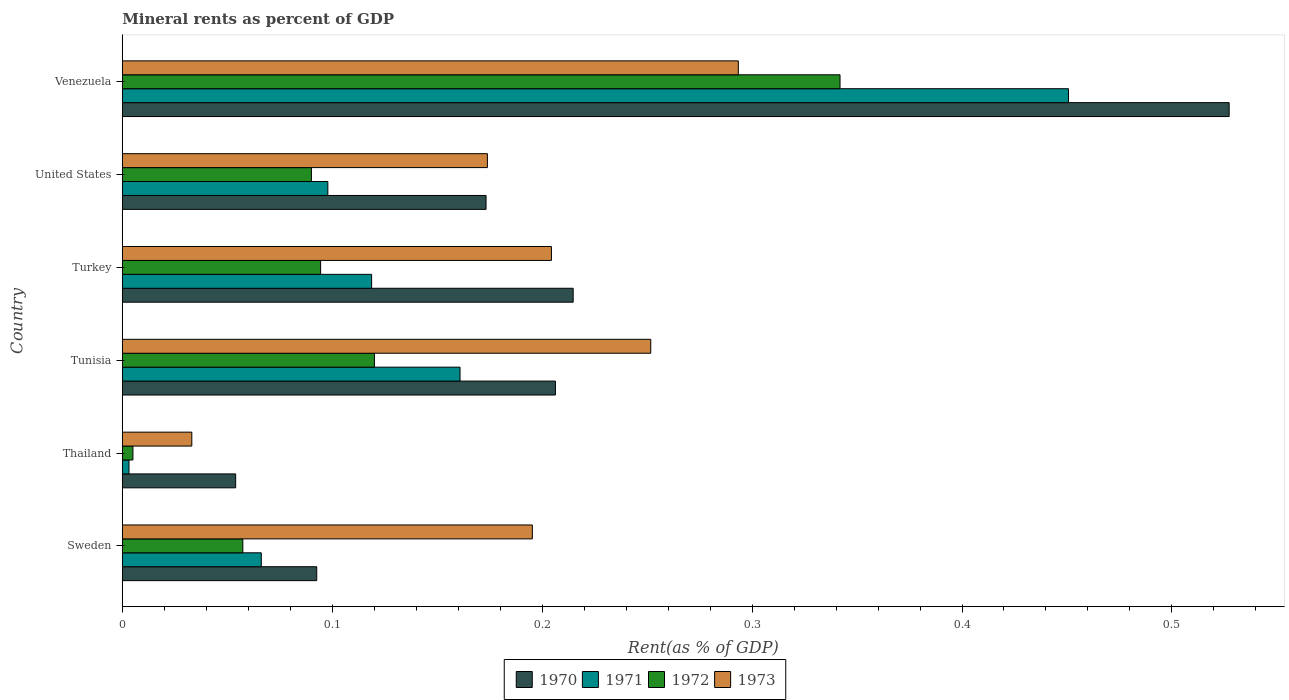How many different coloured bars are there?
Make the answer very short. 4. How many groups of bars are there?
Provide a short and direct response. 6. Are the number of bars per tick equal to the number of legend labels?
Give a very brief answer. Yes. How many bars are there on the 2nd tick from the top?
Offer a terse response. 4. In how many cases, is the number of bars for a given country not equal to the number of legend labels?
Provide a succinct answer. 0. What is the mineral rent in 1973 in Sweden?
Offer a terse response. 0.2. Across all countries, what is the maximum mineral rent in 1973?
Provide a succinct answer. 0.29. Across all countries, what is the minimum mineral rent in 1972?
Offer a terse response. 0.01. In which country was the mineral rent in 1970 maximum?
Provide a short and direct response. Venezuela. In which country was the mineral rent in 1971 minimum?
Your answer should be compact. Thailand. What is the total mineral rent in 1970 in the graph?
Ensure brevity in your answer.  1.27. What is the difference between the mineral rent in 1971 in Thailand and that in Turkey?
Ensure brevity in your answer.  -0.12. What is the difference between the mineral rent in 1973 in Venezuela and the mineral rent in 1971 in Turkey?
Your answer should be compact. 0.17. What is the average mineral rent in 1971 per country?
Keep it short and to the point. 0.15. What is the difference between the mineral rent in 1971 and mineral rent in 1970 in Turkey?
Your answer should be very brief. -0.1. In how many countries, is the mineral rent in 1972 greater than 0.2 %?
Give a very brief answer. 1. What is the ratio of the mineral rent in 1972 in Thailand to that in Venezuela?
Offer a terse response. 0.01. What is the difference between the highest and the second highest mineral rent in 1970?
Your response must be concise. 0.31. What is the difference between the highest and the lowest mineral rent in 1971?
Offer a terse response. 0.45. Is the sum of the mineral rent in 1970 in Tunisia and Venezuela greater than the maximum mineral rent in 1971 across all countries?
Make the answer very short. Yes. Is it the case that in every country, the sum of the mineral rent in 1973 and mineral rent in 1971 is greater than the sum of mineral rent in 1972 and mineral rent in 1970?
Provide a succinct answer. No. What does the 2nd bar from the top in Turkey represents?
Offer a terse response. 1972. How many bars are there?
Keep it short and to the point. 24. Are all the bars in the graph horizontal?
Provide a short and direct response. Yes. How many countries are there in the graph?
Offer a very short reply. 6. Are the values on the major ticks of X-axis written in scientific E-notation?
Offer a terse response. No. How many legend labels are there?
Your response must be concise. 4. What is the title of the graph?
Make the answer very short. Mineral rents as percent of GDP. What is the label or title of the X-axis?
Ensure brevity in your answer.  Rent(as % of GDP). What is the Rent(as % of GDP) of 1970 in Sweden?
Your answer should be very brief. 0.09. What is the Rent(as % of GDP) of 1971 in Sweden?
Keep it short and to the point. 0.07. What is the Rent(as % of GDP) in 1972 in Sweden?
Keep it short and to the point. 0.06. What is the Rent(as % of GDP) in 1973 in Sweden?
Your answer should be very brief. 0.2. What is the Rent(as % of GDP) of 1970 in Thailand?
Your answer should be very brief. 0.05. What is the Rent(as % of GDP) of 1971 in Thailand?
Provide a short and direct response. 0. What is the Rent(as % of GDP) of 1972 in Thailand?
Ensure brevity in your answer.  0.01. What is the Rent(as % of GDP) in 1973 in Thailand?
Offer a terse response. 0.03. What is the Rent(as % of GDP) in 1970 in Tunisia?
Your answer should be very brief. 0.21. What is the Rent(as % of GDP) in 1971 in Tunisia?
Offer a very short reply. 0.16. What is the Rent(as % of GDP) in 1972 in Tunisia?
Your response must be concise. 0.12. What is the Rent(as % of GDP) in 1973 in Tunisia?
Provide a short and direct response. 0.25. What is the Rent(as % of GDP) in 1970 in Turkey?
Ensure brevity in your answer.  0.21. What is the Rent(as % of GDP) of 1971 in Turkey?
Your answer should be compact. 0.12. What is the Rent(as % of GDP) of 1972 in Turkey?
Your response must be concise. 0.09. What is the Rent(as % of GDP) of 1973 in Turkey?
Give a very brief answer. 0.2. What is the Rent(as % of GDP) in 1970 in United States?
Your response must be concise. 0.17. What is the Rent(as % of GDP) of 1971 in United States?
Ensure brevity in your answer.  0.1. What is the Rent(as % of GDP) of 1972 in United States?
Ensure brevity in your answer.  0.09. What is the Rent(as % of GDP) of 1973 in United States?
Your response must be concise. 0.17. What is the Rent(as % of GDP) in 1970 in Venezuela?
Provide a succinct answer. 0.53. What is the Rent(as % of GDP) in 1971 in Venezuela?
Keep it short and to the point. 0.45. What is the Rent(as % of GDP) in 1972 in Venezuela?
Give a very brief answer. 0.34. What is the Rent(as % of GDP) of 1973 in Venezuela?
Offer a very short reply. 0.29. Across all countries, what is the maximum Rent(as % of GDP) in 1970?
Keep it short and to the point. 0.53. Across all countries, what is the maximum Rent(as % of GDP) of 1971?
Provide a succinct answer. 0.45. Across all countries, what is the maximum Rent(as % of GDP) of 1972?
Keep it short and to the point. 0.34. Across all countries, what is the maximum Rent(as % of GDP) in 1973?
Give a very brief answer. 0.29. Across all countries, what is the minimum Rent(as % of GDP) of 1970?
Offer a terse response. 0.05. Across all countries, what is the minimum Rent(as % of GDP) in 1971?
Offer a terse response. 0. Across all countries, what is the minimum Rent(as % of GDP) of 1972?
Provide a short and direct response. 0.01. Across all countries, what is the minimum Rent(as % of GDP) in 1973?
Your answer should be very brief. 0.03. What is the total Rent(as % of GDP) in 1970 in the graph?
Keep it short and to the point. 1.27. What is the total Rent(as % of GDP) in 1971 in the graph?
Your answer should be very brief. 0.9. What is the total Rent(as % of GDP) of 1972 in the graph?
Your response must be concise. 0.71. What is the total Rent(as % of GDP) in 1973 in the graph?
Provide a short and direct response. 1.15. What is the difference between the Rent(as % of GDP) of 1970 in Sweden and that in Thailand?
Provide a short and direct response. 0.04. What is the difference between the Rent(as % of GDP) in 1971 in Sweden and that in Thailand?
Offer a very short reply. 0.06. What is the difference between the Rent(as % of GDP) of 1972 in Sweden and that in Thailand?
Make the answer very short. 0.05. What is the difference between the Rent(as % of GDP) of 1973 in Sweden and that in Thailand?
Provide a short and direct response. 0.16. What is the difference between the Rent(as % of GDP) in 1970 in Sweden and that in Tunisia?
Give a very brief answer. -0.11. What is the difference between the Rent(as % of GDP) of 1971 in Sweden and that in Tunisia?
Ensure brevity in your answer.  -0.09. What is the difference between the Rent(as % of GDP) in 1972 in Sweden and that in Tunisia?
Make the answer very short. -0.06. What is the difference between the Rent(as % of GDP) in 1973 in Sweden and that in Tunisia?
Offer a very short reply. -0.06. What is the difference between the Rent(as % of GDP) of 1970 in Sweden and that in Turkey?
Provide a short and direct response. -0.12. What is the difference between the Rent(as % of GDP) in 1971 in Sweden and that in Turkey?
Keep it short and to the point. -0.05. What is the difference between the Rent(as % of GDP) of 1972 in Sweden and that in Turkey?
Offer a very short reply. -0.04. What is the difference between the Rent(as % of GDP) of 1973 in Sweden and that in Turkey?
Your response must be concise. -0.01. What is the difference between the Rent(as % of GDP) of 1970 in Sweden and that in United States?
Keep it short and to the point. -0.08. What is the difference between the Rent(as % of GDP) of 1971 in Sweden and that in United States?
Ensure brevity in your answer.  -0.03. What is the difference between the Rent(as % of GDP) of 1972 in Sweden and that in United States?
Your response must be concise. -0.03. What is the difference between the Rent(as % of GDP) of 1973 in Sweden and that in United States?
Make the answer very short. 0.02. What is the difference between the Rent(as % of GDP) of 1970 in Sweden and that in Venezuela?
Keep it short and to the point. -0.43. What is the difference between the Rent(as % of GDP) of 1971 in Sweden and that in Venezuela?
Offer a very short reply. -0.38. What is the difference between the Rent(as % of GDP) in 1972 in Sweden and that in Venezuela?
Offer a very short reply. -0.28. What is the difference between the Rent(as % of GDP) in 1973 in Sweden and that in Venezuela?
Make the answer very short. -0.1. What is the difference between the Rent(as % of GDP) in 1970 in Thailand and that in Tunisia?
Your response must be concise. -0.15. What is the difference between the Rent(as % of GDP) of 1971 in Thailand and that in Tunisia?
Provide a succinct answer. -0.16. What is the difference between the Rent(as % of GDP) in 1972 in Thailand and that in Tunisia?
Provide a succinct answer. -0.12. What is the difference between the Rent(as % of GDP) of 1973 in Thailand and that in Tunisia?
Provide a short and direct response. -0.22. What is the difference between the Rent(as % of GDP) of 1970 in Thailand and that in Turkey?
Provide a short and direct response. -0.16. What is the difference between the Rent(as % of GDP) of 1971 in Thailand and that in Turkey?
Offer a terse response. -0.12. What is the difference between the Rent(as % of GDP) of 1972 in Thailand and that in Turkey?
Your response must be concise. -0.09. What is the difference between the Rent(as % of GDP) in 1973 in Thailand and that in Turkey?
Offer a terse response. -0.17. What is the difference between the Rent(as % of GDP) in 1970 in Thailand and that in United States?
Keep it short and to the point. -0.12. What is the difference between the Rent(as % of GDP) of 1971 in Thailand and that in United States?
Keep it short and to the point. -0.09. What is the difference between the Rent(as % of GDP) of 1972 in Thailand and that in United States?
Your answer should be very brief. -0.09. What is the difference between the Rent(as % of GDP) of 1973 in Thailand and that in United States?
Offer a very short reply. -0.14. What is the difference between the Rent(as % of GDP) in 1970 in Thailand and that in Venezuela?
Your answer should be compact. -0.47. What is the difference between the Rent(as % of GDP) of 1971 in Thailand and that in Venezuela?
Provide a succinct answer. -0.45. What is the difference between the Rent(as % of GDP) in 1972 in Thailand and that in Venezuela?
Offer a terse response. -0.34. What is the difference between the Rent(as % of GDP) in 1973 in Thailand and that in Venezuela?
Your answer should be compact. -0.26. What is the difference between the Rent(as % of GDP) in 1970 in Tunisia and that in Turkey?
Keep it short and to the point. -0.01. What is the difference between the Rent(as % of GDP) of 1971 in Tunisia and that in Turkey?
Provide a succinct answer. 0.04. What is the difference between the Rent(as % of GDP) of 1972 in Tunisia and that in Turkey?
Provide a short and direct response. 0.03. What is the difference between the Rent(as % of GDP) of 1973 in Tunisia and that in Turkey?
Your answer should be very brief. 0.05. What is the difference between the Rent(as % of GDP) in 1970 in Tunisia and that in United States?
Ensure brevity in your answer.  0.03. What is the difference between the Rent(as % of GDP) of 1971 in Tunisia and that in United States?
Offer a very short reply. 0.06. What is the difference between the Rent(as % of GDP) of 1973 in Tunisia and that in United States?
Make the answer very short. 0.08. What is the difference between the Rent(as % of GDP) of 1970 in Tunisia and that in Venezuela?
Provide a short and direct response. -0.32. What is the difference between the Rent(as % of GDP) of 1971 in Tunisia and that in Venezuela?
Offer a terse response. -0.29. What is the difference between the Rent(as % of GDP) of 1972 in Tunisia and that in Venezuela?
Offer a terse response. -0.22. What is the difference between the Rent(as % of GDP) in 1973 in Tunisia and that in Venezuela?
Ensure brevity in your answer.  -0.04. What is the difference between the Rent(as % of GDP) of 1970 in Turkey and that in United States?
Ensure brevity in your answer.  0.04. What is the difference between the Rent(as % of GDP) in 1971 in Turkey and that in United States?
Provide a short and direct response. 0.02. What is the difference between the Rent(as % of GDP) in 1972 in Turkey and that in United States?
Your answer should be very brief. 0. What is the difference between the Rent(as % of GDP) of 1973 in Turkey and that in United States?
Make the answer very short. 0.03. What is the difference between the Rent(as % of GDP) in 1970 in Turkey and that in Venezuela?
Make the answer very short. -0.31. What is the difference between the Rent(as % of GDP) of 1971 in Turkey and that in Venezuela?
Your response must be concise. -0.33. What is the difference between the Rent(as % of GDP) of 1972 in Turkey and that in Venezuela?
Your answer should be very brief. -0.25. What is the difference between the Rent(as % of GDP) in 1973 in Turkey and that in Venezuela?
Your answer should be compact. -0.09. What is the difference between the Rent(as % of GDP) in 1970 in United States and that in Venezuela?
Provide a succinct answer. -0.35. What is the difference between the Rent(as % of GDP) in 1971 in United States and that in Venezuela?
Offer a very short reply. -0.35. What is the difference between the Rent(as % of GDP) in 1972 in United States and that in Venezuela?
Your response must be concise. -0.25. What is the difference between the Rent(as % of GDP) of 1973 in United States and that in Venezuela?
Make the answer very short. -0.12. What is the difference between the Rent(as % of GDP) of 1970 in Sweden and the Rent(as % of GDP) of 1971 in Thailand?
Offer a very short reply. 0.09. What is the difference between the Rent(as % of GDP) of 1970 in Sweden and the Rent(as % of GDP) of 1972 in Thailand?
Offer a very short reply. 0.09. What is the difference between the Rent(as % of GDP) of 1970 in Sweden and the Rent(as % of GDP) of 1973 in Thailand?
Your answer should be very brief. 0.06. What is the difference between the Rent(as % of GDP) of 1971 in Sweden and the Rent(as % of GDP) of 1972 in Thailand?
Give a very brief answer. 0.06. What is the difference between the Rent(as % of GDP) in 1971 in Sweden and the Rent(as % of GDP) in 1973 in Thailand?
Provide a succinct answer. 0.03. What is the difference between the Rent(as % of GDP) of 1972 in Sweden and the Rent(as % of GDP) of 1973 in Thailand?
Your response must be concise. 0.02. What is the difference between the Rent(as % of GDP) in 1970 in Sweden and the Rent(as % of GDP) in 1971 in Tunisia?
Make the answer very short. -0.07. What is the difference between the Rent(as % of GDP) of 1970 in Sweden and the Rent(as % of GDP) of 1972 in Tunisia?
Your response must be concise. -0.03. What is the difference between the Rent(as % of GDP) in 1970 in Sweden and the Rent(as % of GDP) in 1973 in Tunisia?
Your answer should be compact. -0.16. What is the difference between the Rent(as % of GDP) in 1971 in Sweden and the Rent(as % of GDP) in 1972 in Tunisia?
Offer a terse response. -0.05. What is the difference between the Rent(as % of GDP) in 1971 in Sweden and the Rent(as % of GDP) in 1973 in Tunisia?
Provide a short and direct response. -0.19. What is the difference between the Rent(as % of GDP) of 1972 in Sweden and the Rent(as % of GDP) of 1973 in Tunisia?
Make the answer very short. -0.19. What is the difference between the Rent(as % of GDP) of 1970 in Sweden and the Rent(as % of GDP) of 1971 in Turkey?
Provide a succinct answer. -0.03. What is the difference between the Rent(as % of GDP) in 1970 in Sweden and the Rent(as % of GDP) in 1972 in Turkey?
Provide a short and direct response. -0. What is the difference between the Rent(as % of GDP) of 1970 in Sweden and the Rent(as % of GDP) of 1973 in Turkey?
Provide a short and direct response. -0.11. What is the difference between the Rent(as % of GDP) of 1971 in Sweden and the Rent(as % of GDP) of 1972 in Turkey?
Offer a very short reply. -0.03. What is the difference between the Rent(as % of GDP) of 1971 in Sweden and the Rent(as % of GDP) of 1973 in Turkey?
Provide a short and direct response. -0.14. What is the difference between the Rent(as % of GDP) of 1972 in Sweden and the Rent(as % of GDP) of 1973 in Turkey?
Offer a terse response. -0.15. What is the difference between the Rent(as % of GDP) in 1970 in Sweden and the Rent(as % of GDP) in 1971 in United States?
Your answer should be compact. -0.01. What is the difference between the Rent(as % of GDP) in 1970 in Sweden and the Rent(as % of GDP) in 1972 in United States?
Offer a terse response. 0. What is the difference between the Rent(as % of GDP) in 1970 in Sweden and the Rent(as % of GDP) in 1973 in United States?
Your response must be concise. -0.08. What is the difference between the Rent(as % of GDP) of 1971 in Sweden and the Rent(as % of GDP) of 1972 in United States?
Offer a very short reply. -0.02. What is the difference between the Rent(as % of GDP) in 1971 in Sweden and the Rent(as % of GDP) in 1973 in United States?
Offer a terse response. -0.11. What is the difference between the Rent(as % of GDP) in 1972 in Sweden and the Rent(as % of GDP) in 1973 in United States?
Ensure brevity in your answer.  -0.12. What is the difference between the Rent(as % of GDP) of 1970 in Sweden and the Rent(as % of GDP) of 1971 in Venezuela?
Offer a very short reply. -0.36. What is the difference between the Rent(as % of GDP) of 1970 in Sweden and the Rent(as % of GDP) of 1972 in Venezuela?
Offer a terse response. -0.25. What is the difference between the Rent(as % of GDP) of 1970 in Sweden and the Rent(as % of GDP) of 1973 in Venezuela?
Offer a terse response. -0.2. What is the difference between the Rent(as % of GDP) of 1971 in Sweden and the Rent(as % of GDP) of 1972 in Venezuela?
Give a very brief answer. -0.28. What is the difference between the Rent(as % of GDP) in 1971 in Sweden and the Rent(as % of GDP) in 1973 in Venezuela?
Offer a very short reply. -0.23. What is the difference between the Rent(as % of GDP) of 1972 in Sweden and the Rent(as % of GDP) of 1973 in Venezuela?
Keep it short and to the point. -0.24. What is the difference between the Rent(as % of GDP) in 1970 in Thailand and the Rent(as % of GDP) in 1971 in Tunisia?
Your answer should be very brief. -0.11. What is the difference between the Rent(as % of GDP) in 1970 in Thailand and the Rent(as % of GDP) in 1972 in Tunisia?
Offer a terse response. -0.07. What is the difference between the Rent(as % of GDP) of 1970 in Thailand and the Rent(as % of GDP) of 1973 in Tunisia?
Your response must be concise. -0.2. What is the difference between the Rent(as % of GDP) of 1971 in Thailand and the Rent(as % of GDP) of 1972 in Tunisia?
Ensure brevity in your answer.  -0.12. What is the difference between the Rent(as % of GDP) in 1971 in Thailand and the Rent(as % of GDP) in 1973 in Tunisia?
Offer a very short reply. -0.25. What is the difference between the Rent(as % of GDP) of 1972 in Thailand and the Rent(as % of GDP) of 1973 in Tunisia?
Your answer should be very brief. -0.25. What is the difference between the Rent(as % of GDP) in 1970 in Thailand and the Rent(as % of GDP) in 1971 in Turkey?
Your answer should be very brief. -0.06. What is the difference between the Rent(as % of GDP) in 1970 in Thailand and the Rent(as % of GDP) in 1972 in Turkey?
Ensure brevity in your answer.  -0.04. What is the difference between the Rent(as % of GDP) in 1970 in Thailand and the Rent(as % of GDP) in 1973 in Turkey?
Make the answer very short. -0.15. What is the difference between the Rent(as % of GDP) of 1971 in Thailand and the Rent(as % of GDP) of 1972 in Turkey?
Offer a very short reply. -0.09. What is the difference between the Rent(as % of GDP) in 1971 in Thailand and the Rent(as % of GDP) in 1973 in Turkey?
Your response must be concise. -0.2. What is the difference between the Rent(as % of GDP) in 1972 in Thailand and the Rent(as % of GDP) in 1973 in Turkey?
Your response must be concise. -0.2. What is the difference between the Rent(as % of GDP) of 1970 in Thailand and the Rent(as % of GDP) of 1971 in United States?
Offer a very short reply. -0.04. What is the difference between the Rent(as % of GDP) of 1970 in Thailand and the Rent(as % of GDP) of 1972 in United States?
Give a very brief answer. -0.04. What is the difference between the Rent(as % of GDP) of 1970 in Thailand and the Rent(as % of GDP) of 1973 in United States?
Your response must be concise. -0.12. What is the difference between the Rent(as % of GDP) in 1971 in Thailand and the Rent(as % of GDP) in 1972 in United States?
Offer a terse response. -0.09. What is the difference between the Rent(as % of GDP) in 1971 in Thailand and the Rent(as % of GDP) in 1973 in United States?
Provide a succinct answer. -0.17. What is the difference between the Rent(as % of GDP) in 1972 in Thailand and the Rent(as % of GDP) in 1973 in United States?
Keep it short and to the point. -0.17. What is the difference between the Rent(as % of GDP) in 1970 in Thailand and the Rent(as % of GDP) in 1971 in Venezuela?
Your answer should be compact. -0.4. What is the difference between the Rent(as % of GDP) in 1970 in Thailand and the Rent(as % of GDP) in 1972 in Venezuela?
Give a very brief answer. -0.29. What is the difference between the Rent(as % of GDP) in 1970 in Thailand and the Rent(as % of GDP) in 1973 in Venezuela?
Offer a very short reply. -0.24. What is the difference between the Rent(as % of GDP) in 1971 in Thailand and the Rent(as % of GDP) in 1972 in Venezuela?
Offer a very short reply. -0.34. What is the difference between the Rent(as % of GDP) in 1971 in Thailand and the Rent(as % of GDP) in 1973 in Venezuela?
Keep it short and to the point. -0.29. What is the difference between the Rent(as % of GDP) in 1972 in Thailand and the Rent(as % of GDP) in 1973 in Venezuela?
Provide a short and direct response. -0.29. What is the difference between the Rent(as % of GDP) of 1970 in Tunisia and the Rent(as % of GDP) of 1971 in Turkey?
Offer a very short reply. 0.09. What is the difference between the Rent(as % of GDP) in 1970 in Tunisia and the Rent(as % of GDP) in 1972 in Turkey?
Ensure brevity in your answer.  0.11. What is the difference between the Rent(as % of GDP) of 1970 in Tunisia and the Rent(as % of GDP) of 1973 in Turkey?
Provide a short and direct response. 0. What is the difference between the Rent(as % of GDP) in 1971 in Tunisia and the Rent(as % of GDP) in 1972 in Turkey?
Your response must be concise. 0.07. What is the difference between the Rent(as % of GDP) of 1971 in Tunisia and the Rent(as % of GDP) of 1973 in Turkey?
Provide a short and direct response. -0.04. What is the difference between the Rent(as % of GDP) of 1972 in Tunisia and the Rent(as % of GDP) of 1973 in Turkey?
Offer a very short reply. -0.08. What is the difference between the Rent(as % of GDP) of 1970 in Tunisia and the Rent(as % of GDP) of 1971 in United States?
Offer a very short reply. 0.11. What is the difference between the Rent(as % of GDP) in 1970 in Tunisia and the Rent(as % of GDP) in 1972 in United States?
Your response must be concise. 0.12. What is the difference between the Rent(as % of GDP) in 1970 in Tunisia and the Rent(as % of GDP) in 1973 in United States?
Provide a short and direct response. 0.03. What is the difference between the Rent(as % of GDP) in 1971 in Tunisia and the Rent(as % of GDP) in 1972 in United States?
Your answer should be compact. 0.07. What is the difference between the Rent(as % of GDP) in 1971 in Tunisia and the Rent(as % of GDP) in 1973 in United States?
Ensure brevity in your answer.  -0.01. What is the difference between the Rent(as % of GDP) of 1972 in Tunisia and the Rent(as % of GDP) of 1973 in United States?
Make the answer very short. -0.05. What is the difference between the Rent(as % of GDP) in 1970 in Tunisia and the Rent(as % of GDP) in 1971 in Venezuela?
Ensure brevity in your answer.  -0.24. What is the difference between the Rent(as % of GDP) in 1970 in Tunisia and the Rent(as % of GDP) in 1972 in Venezuela?
Your response must be concise. -0.14. What is the difference between the Rent(as % of GDP) of 1970 in Tunisia and the Rent(as % of GDP) of 1973 in Venezuela?
Provide a succinct answer. -0.09. What is the difference between the Rent(as % of GDP) in 1971 in Tunisia and the Rent(as % of GDP) in 1972 in Venezuela?
Offer a terse response. -0.18. What is the difference between the Rent(as % of GDP) in 1971 in Tunisia and the Rent(as % of GDP) in 1973 in Venezuela?
Provide a succinct answer. -0.13. What is the difference between the Rent(as % of GDP) in 1972 in Tunisia and the Rent(as % of GDP) in 1973 in Venezuela?
Offer a very short reply. -0.17. What is the difference between the Rent(as % of GDP) in 1970 in Turkey and the Rent(as % of GDP) in 1971 in United States?
Your response must be concise. 0.12. What is the difference between the Rent(as % of GDP) of 1970 in Turkey and the Rent(as % of GDP) of 1972 in United States?
Keep it short and to the point. 0.12. What is the difference between the Rent(as % of GDP) of 1970 in Turkey and the Rent(as % of GDP) of 1973 in United States?
Your response must be concise. 0.04. What is the difference between the Rent(as % of GDP) in 1971 in Turkey and the Rent(as % of GDP) in 1972 in United States?
Ensure brevity in your answer.  0.03. What is the difference between the Rent(as % of GDP) in 1971 in Turkey and the Rent(as % of GDP) in 1973 in United States?
Provide a succinct answer. -0.06. What is the difference between the Rent(as % of GDP) of 1972 in Turkey and the Rent(as % of GDP) of 1973 in United States?
Ensure brevity in your answer.  -0.08. What is the difference between the Rent(as % of GDP) of 1970 in Turkey and the Rent(as % of GDP) of 1971 in Venezuela?
Provide a short and direct response. -0.24. What is the difference between the Rent(as % of GDP) of 1970 in Turkey and the Rent(as % of GDP) of 1972 in Venezuela?
Ensure brevity in your answer.  -0.13. What is the difference between the Rent(as % of GDP) in 1970 in Turkey and the Rent(as % of GDP) in 1973 in Venezuela?
Ensure brevity in your answer.  -0.08. What is the difference between the Rent(as % of GDP) of 1971 in Turkey and the Rent(as % of GDP) of 1972 in Venezuela?
Make the answer very short. -0.22. What is the difference between the Rent(as % of GDP) in 1971 in Turkey and the Rent(as % of GDP) in 1973 in Venezuela?
Offer a very short reply. -0.17. What is the difference between the Rent(as % of GDP) of 1972 in Turkey and the Rent(as % of GDP) of 1973 in Venezuela?
Your response must be concise. -0.2. What is the difference between the Rent(as % of GDP) of 1970 in United States and the Rent(as % of GDP) of 1971 in Venezuela?
Offer a terse response. -0.28. What is the difference between the Rent(as % of GDP) in 1970 in United States and the Rent(as % of GDP) in 1972 in Venezuela?
Provide a short and direct response. -0.17. What is the difference between the Rent(as % of GDP) of 1970 in United States and the Rent(as % of GDP) of 1973 in Venezuela?
Offer a terse response. -0.12. What is the difference between the Rent(as % of GDP) of 1971 in United States and the Rent(as % of GDP) of 1972 in Venezuela?
Offer a terse response. -0.24. What is the difference between the Rent(as % of GDP) in 1971 in United States and the Rent(as % of GDP) in 1973 in Venezuela?
Offer a terse response. -0.2. What is the difference between the Rent(as % of GDP) in 1972 in United States and the Rent(as % of GDP) in 1973 in Venezuela?
Provide a succinct answer. -0.2. What is the average Rent(as % of GDP) of 1970 per country?
Give a very brief answer. 0.21. What is the average Rent(as % of GDP) of 1971 per country?
Provide a short and direct response. 0.15. What is the average Rent(as % of GDP) of 1972 per country?
Your answer should be very brief. 0.12. What is the average Rent(as % of GDP) of 1973 per country?
Your answer should be compact. 0.19. What is the difference between the Rent(as % of GDP) of 1970 and Rent(as % of GDP) of 1971 in Sweden?
Your answer should be compact. 0.03. What is the difference between the Rent(as % of GDP) in 1970 and Rent(as % of GDP) in 1972 in Sweden?
Offer a very short reply. 0.04. What is the difference between the Rent(as % of GDP) of 1970 and Rent(as % of GDP) of 1973 in Sweden?
Offer a very short reply. -0.1. What is the difference between the Rent(as % of GDP) of 1971 and Rent(as % of GDP) of 1972 in Sweden?
Provide a succinct answer. 0.01. What is the difference between the Rent(as % of GDP) of 1971 and Rent(as % of GDP) of 1973 in Sweden?
Give a very brief answer. -0.13. What is the difference between the Rent(as % of GDP) in 1972 and Rent(as % of GDP) in 1973 in Sweden?
Offer a terse response. -0.14. What is the difference between the Rent(as % of GDP) of 1970 and Rent(as % of GDP) of 1971 in Thailand?
Your response must be concise. 0.05. What is the difference between the Rent(as % of GDP) of 1970 and Rent(as % of GDP) of 1972 in Thailand?
Your response must be concise. 0.05. What is the difference between the Rent(as % of GDP) in 1970 and Rent(as % of GDP) in 1973 in Thailand?
Give a very brief answer. 0.02. What is the difference between the Rent(as % of GDP) of 1971 and Rent(as % of GDP) of 1972 in Thailand?
Provide a short and direct response. -0. What is the difference between the Rent(as % of GDP) in 1971 and Rent(as % of GDP) in 1973 in Thailand?
Provide a succinct answer. -0.03. What is the difference between the Rent(as % of GDP) of 1972 and Rent(as % of GDP) of 1973 in Thailand?
Give a very brief answer. -0.03. What is the difference between the Rent(as % of GDP) in 1970 and Rent(as % of GDP) in 1971 in Tunisia?
Offer a terse response. 0.05. What is the difference between the Rent(as % of GDP) of 1970 and Rent(as % of GDP) of 1972 in Tunisia?
Offer a very short reply. 0.09. What is the difference between the Rent(as % of GDP) in 1970 and Rent(as % of GDP) in 1973 in Tunisia?
Your answer should be very brief. -0.05. What is the difference between the Rent(as % of GDP) in 1971 and Rent(as % of GDP) in 1972 in Tunisia?
Provide a succinct answer. 0.04. What is the difference between the Rent(as % of GDP) of 1971 and Rent(as % of GDP) of 1973 in Tunisia?
Provide a succinct answer. -0.09. What is the difference between the Rent(as % of GDP) in 1972 and Rent(as % of GDP) in 1973 in Tunisia?
Make the answer very short. -0.13. What is the difference between the Rent(as % of GDP) in 1970 and Rent(as % of GDP) in 1971 in Turkey?
Your response must be concise. 0.1. What is the difference between the Rent(as % of GDP) of 1970 and Rent(as % of GDP) of 1972 in Turkey?
Your answer should be very brief. 0.12. What is the difference between the Rent(as % of GDP) in 1970 and Rent(as % of GDP) in 1973 in Turkey?
Your answer should be compact. 0.01. What is the difference between the Rent(as % of GDP) in 1971 and Rent(as % of GDP) in 1972 in Turkey?
Your answer should be very brief. 0.02. What is the difference between the Rent(as % of GDP) in 1971 and Rent(as % of GDP) in 1973 in Turkey?
Provide a succinct answer. -0.09. What is the difference between the Rent(as % of GDP) of 1972 and Rent(as % of GDP) of 1973 in Turkey?
Make the answer very short. -0.11. What is the difference between the Rent(as % of GDP) of 1970 and Rent(as % of GDP) of 1971 in United States?
Make the answer very short. 0.08. What is the difference between the Rent(as % of GDP) of 1970 and Rent(as % of GDP) of 1972 in United States?
Make the answer very short. 0.08. What is the difference between the Rent(as % of GDP) of 1970 and Rent(as % of GDP) of 1973 in United States?
Ensure brevity in your answer.  -0. What is the difference between the Rent(as % of GDP) of 1971 and Rent(as % of GDP) of 1972 in United States?
Provide a short and direct response. 0.01. What is the difference between the Rent(as % of GDP) of 1971 and Rent(as % of GDP) of 1973 in United States?
Provide a short and direct response. -0.08. What is the difference between the Rent(as % of GDP) in 1972 and Rent(as % of GDP) in 1973 in United States?
Your response must be concise. -0.08. What is the difference between the Rent(as % of GDP) of 1970 and Rent(as % of GDP) of 1971 in Venezuela?
Your answer should be very brief. 0.08. What is the difference between the Rent(as % of GDP) of 1970 and Rent(as % of GDP) of 1972 in Venezuela?
Your answer should be compact. 0.19. What is the difference between the Rent(as % of GDP) in 1970 and Rent(as % of GDP) in 1973 in Venezuela?
Ensure brevity in your answer.  0.23. What is the difference between the Rent(as % of GDP) of 1971 and Rent(as % of GDP) of 1972 in Venezuela?
Your answer should be very brief. 0.11. What is the difference between the Rent(as % of GDP) of 1971 and Rent(as % of GDP) of 1973 in Venezuela?
Give a very brief answer. 0.16. What is the difference between the Rent(as % of GDP) in 1972 and Rent(as % of GDP) in 1973 in Venezuela?
Your answer should be compact. 0.05. What is the ratio of the Rent(as % of GDP) of 1970 in Sweden to that in Thailand?
Make the answer very short. 1.72. What is the ratio of the Rent(as % of GDP) of 1971 in Sweden to that in Thailand?
Your response must be concise. 20.7. What is the ratio of the Rent(as % of GDP) in 1972 in Sweden to that in Thailand?
Make the answer very short. 11.33. What is the ratio of the Rent(as % of GDP) in 1973 in Sweden to that in Thailand?
Offer a very short reply. 5.9. What is the ratio of the Rent(as % of GDP) in 1970 in Sweden to that in Tunisia?
Your answer should be compact. 0.45. What is the ratio of the Rent(as % of GDP) in 1971 in Sweden to that in Tunisia?
Offer a very short reply. 0.41. What is the ratio of the Rent(as % of GDP) of 1972 in Sweden to that in Tunisia?
Keep it short and to the point. 0.48. What is the ratio of the Rent(as % of GDP) in 1973 in Sweden to that in Tunisia?
Your answer should be very brief. 0.78. What is the ratio of the Rent(as % of GDP) in 1970 in Sweden to that in Turkey?
Your answer should be compact. 0.43. What is the ratio of the Rent(as % of GDP) of 1971 in Sweden to that in Turkey?
Your answer should be very brief. 0.56. What is the ratio of the Rent(as % of GDP) in 1972 in Sweden to that in Turkey?
Provide a short and direct response. 0.61. What is the ratio of the Rent(as % of GDP) of 1973 in Sweden to that in Turkey?
Offer a very short reply. 0.96. What is the ratio of the Rent(as % of GDP) in 1970 in Sweden to that in United States?
Your answer should be very brief. 0.53. What is the ratio of the Rent(as % of GDP) in 1971 in Sweden to that in United States?
Offer a very short reply. 0.68. What is the ratio of the Rent(as % of GDP) in 1972 in Sweden to that in United States?
Your response must be concise. 0.64. What is the ratio of the Rent(as % of GDP) of 1973 in Sweden to that in United States?
Ensure brevity in your answer.  1.12. What is the ratio of the Rent(as % of GDP) in 1970 in Sweden to that in Venezuela?
Your response must be concise. 0.18. What is the ratio of the Rent(as % of GDP) of 1971 in Sweden to that in Venezuela?
Provide a succinct answer. 0.15. What is the ratio of the Rent(as % of GDP) in 1972 in Sweden to that in Venezuela?
Provide a succinct answer. 0.17. What is the ratio of the Rent(as % of GDP) of 1973 in Sweden to that in Venezuela?
Your response must be concise. 0.67. What is the ratio of the Rent(as % of GDP) of 1970 in Thailand to that in Tunisia?
Make the answer very short. 0.26. What is the ratio of the Rent(as % of GDP) of 1971 in Thailand to that in Tunisia?
Provide a succinct answer. 0.02. What is the ratio of the Rent(as % of GDP) in 1972 in Thailand to that in Tunisia?
Provide a succinct answer. 0.04. What is the ratio of the Rent(as % of GDP) in 1973 in Thailand to that in Tunisia?
Your response must be concise. 0.13. What is the ratio of the Rent(as % of GDP) in 1970 in Thailand to that in Turkey?
Offer a terse response. 0.25. What is the ratio of the Rent(as % of GDP) in 1971 in Thailand to that in Turkey?
Your answer should be compact. 0.03. What is the ratio of the Rent(as % of GDP) of 1972 in Thailand to that in Turkey?
Offer a very short reply. 0.05. What is the ratio of the Rent(as % of GDP) of 1973 in Thailand to that in Turkey?
Your answer should be compact. 0.16. What is the ratio of the Rent(as % of GDP) of 1970 in Thailand to that in United States?
Your answer should be very brief. 0.31. What is the ratio of the Rent(as % of GDP) of 1971 in Thailand to that in United States?
Provide a short and direct response. 0.03. What is the ratio of the Rent(as % of GDP) in 1972 in Thailand to that in United States?
Make the answer very short. 0.06. What is the ratio of the Rent(as % of GDP) of 1973 in Thailand to that in United States?
Offer a terse response. 0.19. What is the ratio of the Rent(as % of GDP) in 1970 in Thailand to that in Venezuela?
Offer a terse response. 0.1. What is the ratio of the Rent(as % of GDP) of 1971 in Thailand to that in Venezuela?
Your answer should be compact. 0.01. What is the ratio of the Rent(as % of GDP) of 1972 in Thailand to that in Venezuela?
Offer a terse response. 0.01. What is the ratio of the Rent(as % of GDP) of 1973 in Thailand to that in Venezuela?
Offer a very short reply. 0.11. What is the ratio of the Rent(as % of GDP) in 1970 in Tunisia to that in Turkey?
Your response must be concise. 0.96. What is the ratio of the Rent(as % of GDP) in 1971 in Tunisia to that in Turkey?
Provide a short and direct response. 1.35. What is the ratio of the Rent(as % of GDP) of 1972 in Tunisia to that in Turkey?
Ensure brevity in your answer.  1.27. What is the ratio of the Rent(as % of GDP) in 1973 in Tunisia to that in Turkey?
Make the answer very short. 1.23. What is the ratio of the Rent(as % of GDP) in 1970 in Tunisia to that in United States?
Make the answer very short. 1.19. What is the ratio of the Rent(as % of GDP) of 1971 in Tunisia to that in United States?
Provide a succinct answer. 1.64. What is the ratio of the Rent(as % of GDP) in 1972 in Tunisia to that in United States?
Offer a terse response. 1.33. What is the ratio of the Rent(as % of GDP) of 1973 in Tunisia to that in United States?
Your response must be concise. 1.45. What is the ratio of the Rent(as % of GDP) in 1970 in Tunisia to that in Venezuela?
Make the answer very short. 0.39. What is the ratio of the Rent(as % of GDP) in 1971 in Tunisia to that in Venezuela?
Provide a succinct answer. 0.36. What is the ratio of the Rent(as % of GDP) of 1972 in Tunisia to that in Venezuela?
Provide a short and direct response. 0.35. What is the ratio of the Rent(as % of GDP) of 1973 in Tunisia to that in Venezuela?
Ensure brevity in your answer.  0.86. What is the ratio of the Rent(as % of GDP) in 1970 in Turkey to that in United States?
Your answer should be compact. 1.24. What is the ratio of the Rent(as % of GDP) in 1971 in Turkey to that in United States?
Offer a terse response. 1.21. What is the ratio of the Rent(as % of GDP) in 1972 in Turkey to that in United States?
Your answer should be very brief. 1.05. What is the ratio of the Rent(as % of GDP) of 1973 in Turkey to that in United States?
Keep it short and to the point. 1.18. What is the ratio of the Rent(as % of GDP) in 1970 in Turkey to that in Venezuela?
Keep it short and to the point. 0.41. What is the ratio of the Rent(as % of GDP) in 1971 in Turkey to that in Venezuela?
Ensure brevity in your answer.  0.26. What is the ratio of the Rent(as % of GDP) of 1972 in Turkey to that in Venezuela?
Ensure brevity in your answer.  0.28. What is the ratio of the Rent(as % of GDP) of 1973 in Turkey to that in Venezuela?
Provide a succinct answer. 0.7. What is the ratio of the Rent(as % of GDP) in 1970 in United States to that in Venezuela?
Keep it short and to the point. 0.33. What is the ratio of the Rent(as % of GDP) in 1971 in United States to that in Venezuela?
Provide a short and direct response. 0.22. What is the ratio of the Rent(as % of GDP) in 1972 in United States to that in Venezuela?
Ensure brevity in your answer.  0.26. What is the ratio of the Rent(as % of GDP) in 1973 in United States to that in Venezuela?
Your response must be concise. 0.59. What is the difference between the highest and the second highest Rent(as % of GDP) of 1970?
Your answer should be compact. 0.31. What is the difference between the highest and the second highest Rent(as % of GDP) of 1971?
Ensure brevity in your answer.  0.29. What is the difference between the highest and the second highest Rent(as % of GDP) in 1972?
Provide a short and direct response. 0.22. What is the difference between the highest and the second highest Rent(as % of GDP) in 1973?
Make the answer very short. 0.04. What is the difference between the highest and the lowest Rent(as % of GDP) in 1970?
Give a very brief answer. 0.47. What is the difference between the highest and the lowest Rent(as % of GDP) in 1971?
Your response must be concise. 0.45. What is the difference between the highest and the lowest Rent(as % of GDP) in 1972?
Offer a terse response. 0.34. What is the difference between the highest and the lowest Rent(as % of GDP) in 1973?
Offer a very short reply. 0.26. 